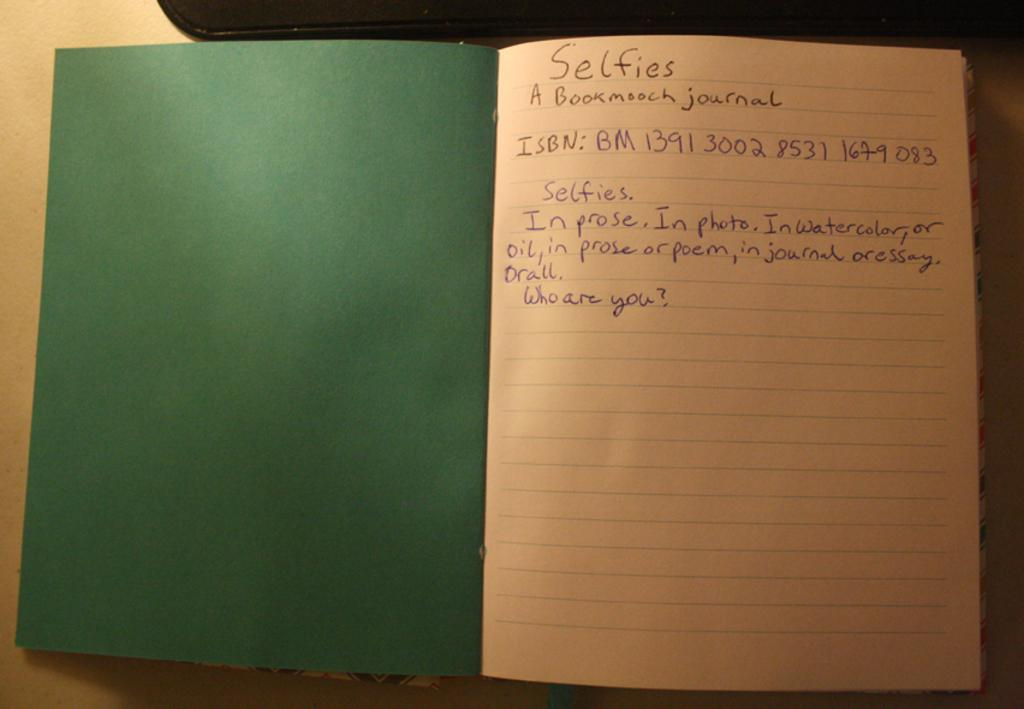<image>
Create a compact narrative representing the image presented. a notebook that has 'selfies' handwritten at the top 